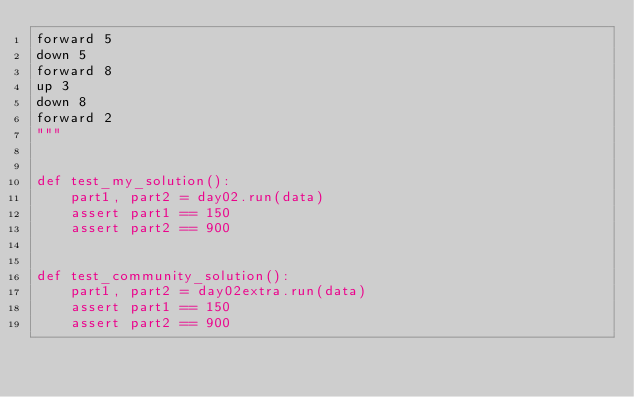<code> <loc_0><loc_0><loc_500><loc_500><_Python_>forward 5
down 5
forward 8
up 3
down 8
forward 2
"""


def test_my_solution():
    part1, part2 = day02.run(data)
    assert part1 == 150
    assert part2 == 900


def test_community_solution():
    part1, part2 = day02extra.run(data)
    assert part1 == 150
    assert part2 == 900
</code> 